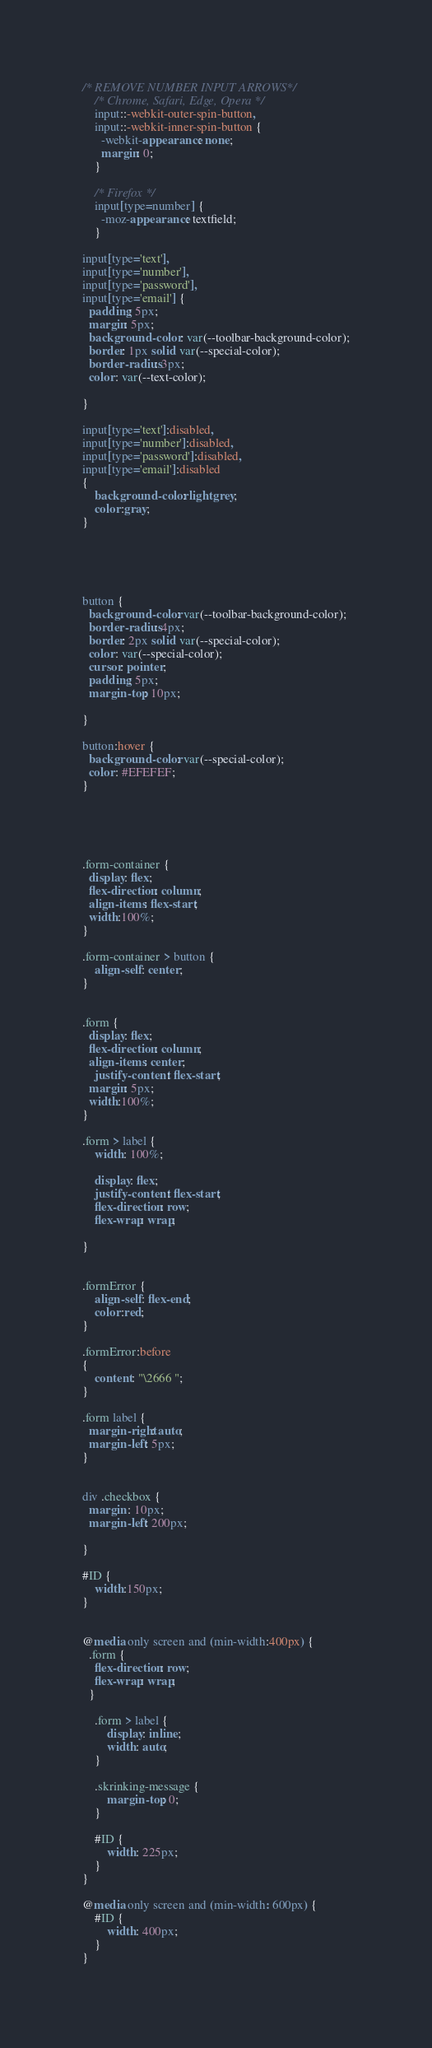<code> <loc_0><loc_0><loc_500><loc_500><_CSS_>/* REMOVE NUMBER INPUT ARROWS*/
	/* Chrome, Safari, Edge, Opera */
	input::-webkit-outer-spin-button,
	input::-webkit-inner-spin-button {
	  -webkit-appearance: none;
	  margin: 0;
	}

	/* Firefox */
	input[type=number] {
	  -moz-appearance: textfield;
	}

input[type='text'],
input[type='number'],
input[type='password'],
input[type='email'] {
  padding: 5px;
  margin: 5px;
  background-color : var(--toolbar-background-color);
  border: 1px solid var(--special-color);
  border-radius: 3px;
  color: var(--text-color);

}

input[type='text']:disabled,
input[type='number']:disabled,
input[type='password']:disabled,
input[type='email']:disabled
{
	background-color: lightgrey;
	color:gray;
}





button {
  background-color: var(--toolbar-background-color);
  border-radius: 4px;
  border: 2px solid var(--special-color);
  color: var(--special-color);
  cursor: pointer;
  padding: 5px;
  margin-top: 10px;

}

button:hover {
  background-color: var(--special-color);
  color: #EFEFEF;
}





.form-container {
  display: flex;
  flex-direction: column;
  align-items: flex-start;
  width:100%;
}

.form-container > button {
	align-self: center;
}


.form {
  display: flex;
  flex-direction: column;
  align-items: center;
	justify-content: flex-start;
  margin: 5px;
  width:100%;
}

.form > label {
	width: 100%;
	
	display: flex;
	justify-content: flex-start;
	flex-direction: row;
	flex-wrap: wrap;
	
}


.formError {
	align-self: flex-end;
	color:red;
}

.formError:before
{
	content: "\2666 ";
}

.form label {
  margin-right: auto;
  margin-left: 5px;
}


div .checkbox {
  margin : 10px;
  margin-left: 200px;
  
}

#ID {
	width:150px;
}


@media only screen and (min-width:400px) {
  .form {
    flex-direction: row;
    flex-wrap: wrap;
  }
	
	.form > label {
		display: inline;
		width: auto;
	}
	
	.skrinking-message {
		margin-top: 0;
	}
	
	#ID {
		width: 225px;
	}
}

@media only screen and (min-width: 600px) {
	#ID {
		width: 400px;
	}
}</code> 